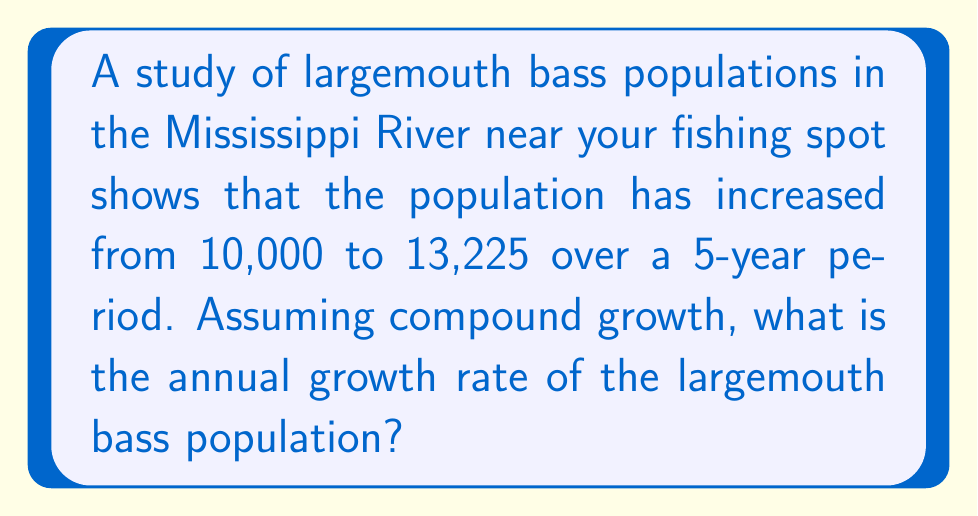Give your solution to this math problem. To solve this problem, we'll use the compound growth formula:

$$A = P(1 + r)^t$$

Where:
$A$ = Final amount
$P$ = Initial amount
$r$ = Annual growth rate (as a decimal)
$t$ = Number of years

We know:
$A = 13,225$
$P = 10,000$
$t = 5$ years

Let's substitute these values into the equation:

$$13,225 = 10,000(1 + r)^5$$

Now, we need to solve for $r$:

1) Divide both sides by 10,000:
   $$1.3225 = (1 + r)^5$$

2) Take the 5th root of both sides:
   $$\sqrt[5]{1.3225} = 1 + r$$

3) Subtract 1 from both sides:
   $$\sqrt[5]{1.3225} - 1 = r$$

4) Calculate the result:
   $$r = 1.0574 - 1 = 0.0574$$

5) Convert to a percentage:
   $$r = 0.0574 \times 100\% = 5.74\%$$

Therefore, the annual compound growth rate is approximately 5.74%.
Answer: The annual compound growth rate of the largemouth bass population is 5.74%. 